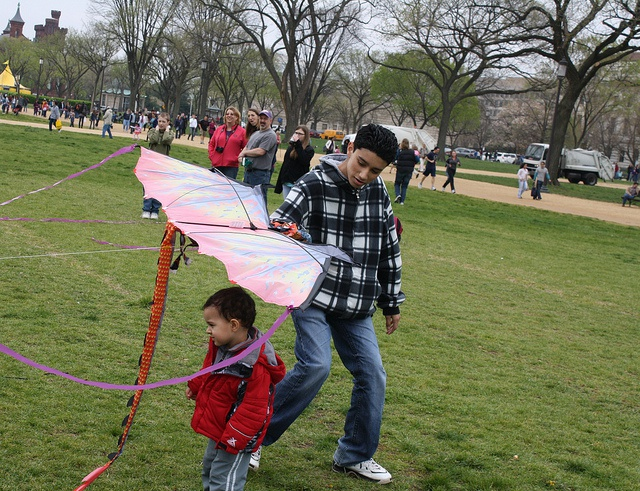Describe the objects in this image and their specific colors. I can see people in lavender, black, gray, navy, and darkblue tones, kite in lavender, magenta, pink, and brown tones, people in lavender, maroon, black, brown, and gray tones, people in lavender, black, gray, darkgreen, and darkgray tones, and people in lavender, brown, black, and maroon tones in this image. 